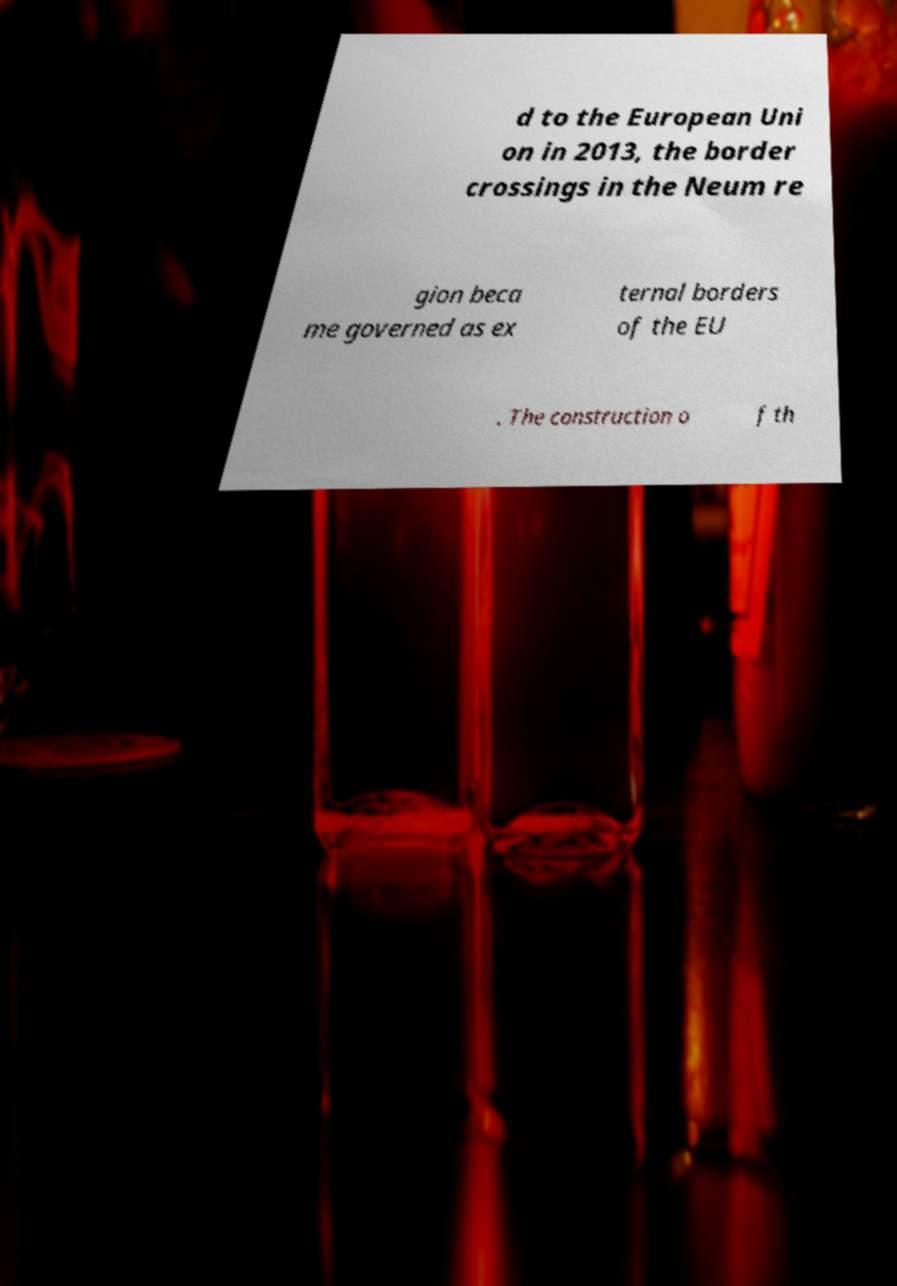Please read and relay the text visible in this image. What does it say? d to the European Uni on in 2013, the border crossings in the Neum re gion beca me governed as ex ternal borders of the EU . The construction o f th 